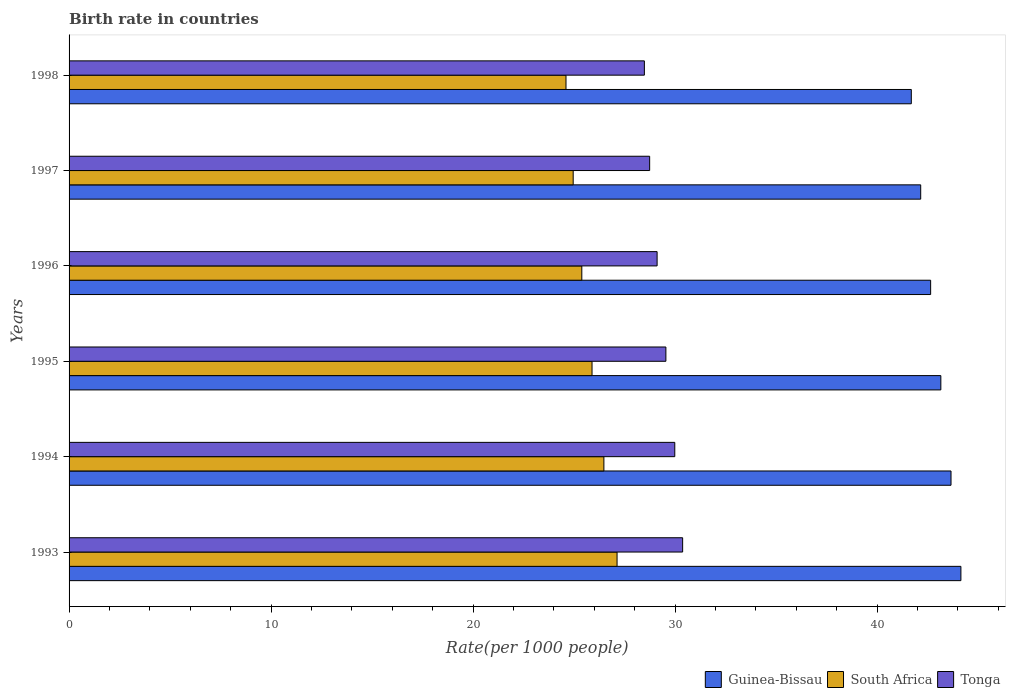Are the number of bars on each tick of the Y-axis equal?
Your answer should be very brief. Yes. How many bars are there on the 1st tick from the bottom?
Ensure brevity in your answer.  3. In how many cases, is the number of bars for a given year not equal to the number of legend labels?
Your response must be concise. 0. What is the birth rate in South Africa in 1996?
Give a very brief answer. 25.38. Across all years, what is the maximum birth rate in Guinea-Bissau?
Your response must be concise. 44.15. Across all years, what is the minimum birth rate in Tonga?
Provide a succinct answer. 28.48. In which year was the birth rate in Guinea-Bissau maximum?
Provide a succinct answer. 1993. In which year was the birth rate in Tonga minimum?
Provide a short and direct response. 1998. What is the total birth rate in Tonga in the graph?
Provide a short and direct response. 176.22. What is the difference between the birth rate in South Africa in 1995 and that in 1997?
Your answer should be very brief. 0.93. What is the difference between the birth rate in South Africa in 1993 and the birth rate in Tonga in 1996?
Make the answer very short. -1.98. What is the average birth rate in Guinea-Bissau per year?
Make the answer very short. 42.91. In the year 1996, what is the difference between the birth rate in Guinea-Bissau and birth rate in South Africa?
Offer a very short reply. 17.27. What is the ratio of the birth rate in South Africa in 1997 to that in 1998?
Make the answer very short. 1.01. Is the birth rate in South Africa in 1994 less than that in 1995?
Provide a short and direct response. No. What is the difference between the highest and the second highest birth rate in Tonga?
Provide a short and direct response. 0.39. What is the difference between the highest and the lowest birth rate in South Africa?
Your answer should be compact. 2.53. In how many years, is the birth rate in Guinea-Bissau greater than the average birth rate in Guinea-Bissau taken over all years?
Your response must be concise. 3. Is the sum of the birth rate in South Africa in 1995 and 1996 greater than the maximum birth rate in Guinea-Bissau across all years?
Ensure brevity in your answer.  Yes. What does the 3rd bar from the top in 1996 represents?
Keep it short and to the point. Guinea-Bissau. What does the 1st bar from the bottom in 1993 represents?
Your answer should be very brief. Guinea-Bissau. Is it the case that in every year, the sum of the birth rate in South Africa and birth rate in Tonga is greater than the birth rate in Guinea-Bissau?
Make the answer very short. Yes. Are all the bars in the graph horizontal?
Keep it short and to the point. Yes. What is the difference between two consecutive major ticks on the X-axis?
Your answer should be very brief. 10. Does the graph contain any zero values?
Offer a terse response. No. Does the graph contain grids?
Offer a very short reply. No. What is the title of the graph?
Offer a very short reply. Birth rate in countries. What is the label or title of the X-axis?
Provide a succinct answer. Rate(per 1000 people). What is the Rate(per 1000 people) in Guinea-Bissau in 1993?
Offer a terse response. 44.15. What is the Rate(per 1000 people) in South Africa in 1993?
Ensure brevity in your answer.  27.13. What is the Rate(per 1000 people) of Tonga in 1993?
Offer a very short reply. 30.37. What is the Rate(per 1000 people) of Guinea-Bissau in 1994?
Offer a very short reply. 43.66. What is the Rate(per 1000 people) in South Africa in 1994?
Your answer should be compact. 26.47. What is the Rate(per 1000 people) of Tonga in 1994?
Offer a very short reply. 29.98. What is the Rate(per 1000 people) in Guinea-Bissau in 1995?
Make the answer very short. 43.15. What is the Rate(per 1000 people) in South Africa in 1995?
Your response must be concise. 25.89. What is the Rate(per 1000 people) of Tonga in 1995?
Your response must be concise. 29.54. What is the Rate(per 1000 people) of Guinea-Bissau in 1996?
Keep it short and to the point. 42.65. What is the Rate(per 1000 people) of South Africa in 1996?
Make the answer very short. 25.38. What is the Rate(per 1000 people) of Tonga in 1996?
Your response must be concise. 29.11. What is the Rate(per 1000 people) of Guinea-Bissau in 1997?
Provide a short and direct response. 42.16. What is the Rate(per 1000 people) of South Africa in 1997?
Offer a very short reply. 24.95. What is the Rate(per 1000 people) in Tonga in 1997?
Your answer should be compact. 28.74. What is the Rate(per 1000 people) of Guinea-Bissau in 1998?
Offer a very short reply. 41.69. What is the Rate(per 1000 people) in South Africa in 1998?
Your answer should be very brief. 24.6. What is the Rate(per 1000 people) in Tonga in 1998?
Offer a very short reply. 28.48. Across all years, what is the maximum Rate(per 1000 people) of Guinea-Bissau?
Keep it short and to the point. 44.15. Across all years, what is the maximum Rate(per 1000 people) of South Africa?
Your answer should be very brief. 27.13. Across all years, what is the maximum Rate(per 1000 people) in Tonga?
Offer a terse response. 30.37. Across all years, what is the minimum Rate(per 1000 people) of Guinea-Bissau?
Ensure brevity in your answer.  41.69. Across all years, what is the minimum Rate(per 1000 people) in South Africa?
Make the answer very short. 24.6. Across all years, what is the minimum Rate(per 1000 people) of Tonga?
Keep it short and to the point. 28.48. What is the total Rate(per 1000 people) in Guinea-Bissau in the graph?
Your answer should be compact. 257.45. What is the total Rate(per 1000 people) in South Africa in the graph?
Your response must be concise. 154.42. What is the total Rate(per 1000 people) in Tonga in the graph?
Ensure brevity in your answer.  176.22. What is the difference between the Rate(per 1000 people) of Guinea-Bissau in 1993 and that in 1994?
Provide a succinct answer. 0.49. What is the difference between the Rate(per 1000 people) of South Africa in 1993 and that in 1994?
Offer a terse response. 0.65. What is the difference between the Rate(per 1000 people) of Tonga in 1993 and that in 1994?
Ensure brevity in your answer.  0.39. What is the difference between the Rate(per 1000 people) of South Africa in 1993 and that in 1995?
Keep it short and to the point. 1.24. What is the difference between the Rate(per 1000 people) in Tonga in 1993 and that in 1995?
Your answer should be compact. 0.83. What is the difference between the Rate(per 1000 people) of Guinea-Bissau in 1993 and that in 1996?
Ensure brevity in your answer.  1.5. What is the difference between the Rate(per 1000 people) in South Africa in 1993 and that in 1996?
Give a very brief answer. 1.75. What is the difference between the Rate(per 1000 people) of Tonga in 1993 and that in 1996?
Give a very brief answer. 1.26. What is the difference between the Rate(per 1000 people) in Guinea-Bissau in 1993 and that in 1997?
Provide a succinct answer. 1.99. What is the difference between the Rate(per 1000 people) of South Africa in 1993 and that in 1997?
Make the answer very short. 2.17. What is the difference between the Rate(per 1000 people) of Tonga in 1993 and that in 1997?
Give a very brief answer. 1.63. What is the difference between the Rate(per 1000 people) in Guinea-Bissau in 1993 and that in 1998?
Provide a succinct answer. 2.46. What is the difference between the Rate(per 1000 people) in South Africa in 1993 and that in 1998?
Keep it short and to the point. 2.53. What is the difference between the Rate(per 1000 people) in Tonga in 1993 and that in 1998?
Provide a succinct answer. 1.89. What is the difference between the Rate(per 1000 people) of Guinea-Bissau in 1994 and that in 1995?
Keep it short and to the point. 0.5. What is the difference between the Rate(per 1000 people) of South Africa in 1994 and that in 1995?
Offer a very short reply. 0.59. What is the difference between the Rate(per 1000 people) in Tonga in 1994 and that in 1995?
Keep it short and to the point. 0.44. What is the difference between the Rate(per 1000 people) of Guinea-Bissau in 1994 and that in 1996?
Provide a succinct answer. 1.01. What is the difference between the Rate(per 1000 people) in South Africa in 1994 and that in 1996?
Your answer should be very brief. 1.09. What is the difference between the Rate(per 1000 people) of Guinea-Bissau in 1994 and that in 1997?
Provide a short and direct response. 1.5. What is the difference between the Rate(per 1000 people) in South Africa in 1994 and that in 1997?
Ensure brevity in your answer.  1.52. What is the difference between the Rate(per 1000 people) in Tonga in 1994 and that in 1997?
Your answer should be very brief. 1.24. What is the difference between the Rate(per 1000 people) of Guinea-Bissau in 1994 and that in 1998?
Your response must be concise. 1.97. What is the difference between the Rate(per 1000 people) in South Africa in 1994 and that in 1998?
Offer a very short reply. 1.88. What is the difference between the Rate(per 1000 people) in Tonga in 1994 and that in 1998?
Ensure brevity in your answer.  1.5. What is the difference between the Rate(per 1000 people) in Guinea-Bissau in 1995 and that in 1996?
Ensure brevity in your answer.  0.51. What is the difference between the Rate(per 1000 people) in South Africa in 1995 and that in 1996?
Give a very brief answer. 0.51. What is the difference between the Rate(per 1000 people) in Tonga in 1995 and that in 1996?
Your response must be concise. 0.43. What is the difference between the Rate(per 1000 people) of South Africa in 1995 and that in 1997?
Make the answer very short. 0.93. What is the difference between the Rate(per 1000 people) of Tonga in 1995 and that in 1997?
Give a very brief answer. 0.8. What is the difference between the Rate(per 1000 people) in Guinea-Bissau in 1995 and that in 1998?
Ensure brevity in your answer.  1.46. What is the difference between the Rate(per 1000 people) of South Africa in 1995 and that in 1998?
Offer a very short reply. 1.29. What is the difference between the Rate(per 1000 people) in Tonga in 1995 and that in 1998?
Provide a succinct answer. 1.06. What is the difference between the Rate(per 1000 people) of Guinea-Bissau in 1996 and that in 1997?
Give a very brief answer. 0.49. What is the difference between the Rate(per 1000 people) in South Africa in 1996 and that in 1997?
Your response must be concise. 0.43. What is the difference between the Rate(per 1000 people) in Tonga in 1996 and that in 1997?
Provide a succinct answer. 0.37. What is the difference between the Rate(per 1000 people) of Guinea-Bissau in 1996 and that in 1998?
Ensure brevity in your answer.  0.96. What is the difference between the Rate(per 1000 people) in South Africa in 1996 and that in 1998?
Your answer should be compact. 0.78. What is the difference between the Rate(per 1000 people) of Tonga in 1996 and that in 1998?
Give a very brief answer. 0.63. What is the difference between the Rate(per 1000 people) in Guinea-Bissau in 1997 and that in 1998?
Offer a terse response. 0.47. What is the difference between the Rate(per 1000 people) of South Africa in 1997 and that in 1998?
Your answer should be compact. 0.36. What is the difference between the Rate(per 1000 people) of Tonga in 1997 and that in 1998?
Your answer should be very brief. 0.26. What is the difference between the Rate(per 1000 people) of Guinea-Bissau in 1993 and the Rate(per 1000 people) of South Africa in 1994?
Your answer should be compact. 17.67. What is the difference between the Rate(per 1000 people) of Guinea-Bissau in 1993 and the Rate(per 1000 people) of Tonga in 1994?
Keep it short and to the point. 14.16. What is the difference between the Rate(per 1000 people) in South Africa in 1993 and the Rate(per 1000 people) in Tonga in 1994?
Keep it short and to the point. -2.86. What is the difference between the Rate(per 1000 people) in Guinea-Bissau in 1993 and the Rate(per 1000 people) in South Africa in 1995?
Offer a terse response. 18.26. What is the difference between the Rate(per 1000 people) in Guinea-Bissau in 1993 and the Rate(per 1000 people) in Tonga in 1995?
Your answer should be very brief. 14.6. What is the difference between the Rate(per 1000 people) of South Africa in 1993 and the Rate(per 1000 people) of Tonga in 1995?
Provide a succinct answer. -2.42. What is the difference between the Rate(per 1000 people) in Guinea-Bissau in 1993 and the Rate(per 1000 people) in South Africa in 1996?
Offer a terse response. 18.77. What is the difference between the Rate(per 1000 people) in Guinea-Bissau in 1993 and the Rate(per 1000 people) in Tonga in 1996?
Your answer should be very brief. 15.04. What is the difference between the Rate(per 1000 people) in South Africa in 1993 and the Rate(per 1000 people) in Tonga in 1996?
Provide a short and direct response. -1.98. What is the difference between the Rate(per 1000 people) in Guinea-Bissau in 1993 and the Rate(per 1000 people) in South Africa in 1997?
Ensure brevity in your answer.  19.19. What is the difference between the Rate(per 1000 people) of Guinea-Bissau in 1993 and the Rate(per 1000 people) of Tonga in 1997?
Make the answer very short. 15.41. What is the difference between the Rate(per 1000 people) in South Africa in 1993 and the Rate(per 1000 people) in Tonga in 1997?
Your answer should be compact. -1.61. What is the difference between the Rate(per 1000 people) of Guinea-Bissau in 1993 and the Rate(per 1000 people) of South Africa in 1998?
Provide a short and direct response. 19.55. What is the difference between the Rate(per 1000 people) of Guinea-Bissau in 1993 and the Rate(per 1000 people) of Tonga in 1998?
Provide a short and direct response. 15.67. What is the difference between the Rate(per 1000 people) in South Africa in 1993 and the Rate(per 1000 people) in Tonga in 1998?
Your answer should be very brief. -1.35. What is the difference between the Rate(per 1000 people) in Guinea-Bissau in 1994 and the Rate(per 1000 people) in South Africa in 1995?
Provide a succinct answer. 17.77. What is the difference between the Rate(per 1000 people) in Guinea-Bissau in 1994 and the Rate(per 1000 people) in Tonga in 1995?
Offer a terse response. 14.11. What is the difference between the Rate(per 1000 people) of South Africa in 1994 and the Rate(per 1000 people) of Tonga in 1995?
Your answer should be compact. -3.07. What is the difference between the Rate(per 1000 people) of Guinea-Bissau in 1994 and the Rate(per 1000 people) of South Africa in 1996?
Provide a succinct answer. 18.28. What is the difference between the Rate(per 1000 people) in Guinea-Bissau in 1994 and the Rate(per 1000 people) in Tonga in 1996?
Your answer should be compact. 14.55. What is the difference between the Rate(per 1000 people) of South Africa in 1994 and the Rate(per 1000 people) of Tonga in 1996?
Offer a very short reply. -2.63. What is the difference between the Rate(per 1000 people) in Guinea-Bissau in 1994 and the Rate(per 1000 people) in South Africa in 1997?
Your answer should be compact. 18.7. What is the difference between the Rate(per 1000 people) of Guinea-Bissau in 1994 and the Rate(per 1000 people) of Tonga in 1997?
Offer a terse response. 14.92. What is the difference between the Rate(per 1000 people) in South Africa in 1994 and the Rate(per 1000 people) in Tonga in 1997?
Offer a very short reply. -2.27. What is the difference between the Rate(per 1000 people) of Guinea-Bissau in 1994 and the Rate(per 1000 people) of South Africa in 1998?
Offer a very short reply. 19.06. What is the difference between the Rate(per 1000 people) in Guinea-Bissau in 1994 and the Rate(per 1000 people) in Tonga in 1998?
Ensure brevity in your answer.  15.18. What is the difference between the Rate(per 1000 people) in South Africa in 1994 and the Rate(per 1000 people) in Tonga in 1998?
Your answer should be very brief. -2. What is the difference between the Rate(per 1000 people) of Guinea-Bissau in 1995 and the Rate(per 1000 people) of South Africa in 1996?
Provide a short and direct response. 17.77. What is the difference between the Rate(per 1000 people) of Guinea-Bissau in 1995 and the Rate(per 1000 people) of Tonga in 1996?
Your answer should be compact. 14.04. What is the difference between the Rate(per 1000 people) in South Africa in 1995 and the Rate(per 1000 people) in Tonga in 1996?
Offer a terse response. -3.22. What is the difference between the Rate(per 1000 people) of Guinea-Bissau in 1995 and the Rate(per 1000 people) of South Africa in 1997?
Ensure brevity in your answer.  18.2. What is the difference between the Rate(per 1000 people) in Guinea-Bissau in 1995 and the Rate(per 1000 people) in Tonga in 1997?
Your response must be concise. 14.41. What is the difference between the Rate(per 1000 people) of South Africa in 1995 and the Rate(per 1000 people) of Tonga in 1997?
Offer a terse response. -2.85. What is the difference between the Rate(per 1000 people) of Guinea-Bissau in 1995 and the Rate(per 1000 people) of South Africa in 1998?
Your response must be concise. 18.55. What is the difference between the Rate(per 1000 people) of Guinea-Bissau in 1995 and the Rate(per 1000 people) of Tonga in 1998?
Ensure brevity in your answer.  14.68. What is the difference between the Rate(per 1000 people) of South Africa in 1995 and the Rate(per 1000 people) of Tonga in 1998?
Keep it short and to the point. -2.59. What is the difference between the Rate(per 1000 people) of Guinea-Bissau in 1996 and the Rate(per 1000 people) of South Africa in 1997?
Give a very brief answer. 17.69. What is the difference between the Rate(per 1000 people) of Guinea-Bissau in 1996 and the Rate(per 1000 people) of Tonga in 1997?
Your response must be concise. 13.91. What is the difference between the Rate(per 1000 people) in South Africa in 1996 and the Rate(per 1000 people) in Tonga in 1997?
Your answer should be very brief. -3.36. What is the difference between the Rate(per 1000 people) of Guinea-Bissau in 1996 and the Rate(per 1000 people) of South Africa in 1998?
Ensure brevity in your answer.  18.05. What is the difference between the Rate(per 1000 people) of Guinea-Bissau in 1996 and the Rate(per 1000 people) of Tonga in 1998?
Your answer should be compact. 14.17. What is the difference between the Rate(per 1000 people) of South Africa in 1996 and the Rate(per 1000 people) of Tonga in 1998?
Offer a terse response. -3.1. What is the difference between the Rate(per 1000 people) of Guinea-Bissau in 1997 and the Rate(per 1000 people) of South Africa in 1998?
Your answer should be very brief. 17.56. What is the difference between the Rate(per 1000 people) of Guinea-Bissau in 1997 and the Rate(per 1000 people) of Tonga in 1998?
Your answer should be compact. 13.68. What is the difference between the Rate(per 1000 people) of South Africa in 1997 and the Rate(per 1000 people) of Tonga in 1998?
Give a very brief answer. -3.52. What is the average Rate(per 1000 people) of Guinea-Bissau per year?
Offer a terse response. 42.91. What is the average Rate(per 1000 people) of South Africa per year?
Your answer should be very brief. 25.74. What is the average Rate(per 1000 people) in Tonga per year?
Your response must be concise. 29.37. In the year 1993, what is the difference between the Rate(per 1000 people) in Guinea-Bissau and Rate(per 1000 people) in South Africa?
Your answer should be compact. 17.02. In the year 1993, what is the difference between the Rate(per 1000 people) in Guinea-Bissau and Rate(per 1000 people) in Tonga?
Provide a short and direct response. 13.77. In the year 1993, what is the difference between the Rate(per 1000 people) of South Africa and Rate(per 1000 people) of Tonga?
Provide a short and direct response. -3.25. In the year 1994, what is the difference between the Rate(per 1000 people) in Guinea-Bissau and Rate(per 1000 people) in South Africa?
Give a very brief answer. 17.18. In the year 1994, what is the difference between the Rate(per 1000 people) of Guinea-Bissau and Rate(per 1000 people) of Tonga?
Make the answer very short. 13.67. In the year 1994, what is the difference between the Rate(per 1000 people) in South Africa and Rate(per 1000 people) in Tonga?
Give a very brief answer. -3.51. In the year 1995, what is the difference between the Rate(per 1000 people) of Guinea-Bissau and Rate(per 1000 people) of South Africa?
Your answer should be very brief. 17.27. In the year 1995, what is the difference between the Rate(per 1000 people) in Guinea-Bissau and Rate(per 1000 people) in Tonga?
Your answer should be very brief. 13.61. In the year 1995, what is the difference between the Rate(per 1000 people) in South Africa and Rate(per 1000 people) in Tonga?
Offer a very short reply. -3.66. In the year 1996, what is the difference between the Rate(per 1000 people) in Guinea-Bissau and Rate(per 1000 people) in South Africa?
Your answer should be very brief. 17.27. In the year 1996, what is the difference between the Rate(per 1000 people) in Guinea-Bissau and Rate(per 1000 people) in Tonga?
Your response must be concise. 13.54. In the year 1996, what is the difference between the Rate(per 1000 people) in South Africa and Rate(per 1000 people) in Tonga?
Offer a terse response. -3.73. In the year 1997, what is the difference between the Rate(per 1000 people) in Guinea-Bissau and Rate(per 1000 people) in South Africa?
Ensure brevity in your answer.  17.2. In the year 1997, what is the difference between the Rate(per 1000 people) in Guinea-Bissau and Rate(per 1000 people) in Tonga?
Your answer should be very brief. 13.42. In the year 1997, what is the difference between the Rate(per 1000 people) in South Africa and Rate(per 1000 people) in Tonga?
Provide a succinct answer. -3.79. In the year 1998, what is the difference between the Rate(per 1000 people) of Guinea-Bissau and Rate(per 1000 people) of South Africa?
Your answer should be compact. 17.09. In the year 1998, what is the difference between the Rate(per 1000 people) of Guinea-Bissau and Rate(per 1000 people) of Tonga?
Give a very brief answer. 13.21. In the year 1998, what is the difference between the Rate(per 1000 people) of South Africa and Rate(per 1000 people) of Tonga?
Your answer should be compact. -3.88. What is the ratio of the Rate(per 1000 people) in Guinea-Bissau in 1993 to that in 1994?
Provide a succinct answer. 1.01. What is the ratio of the Rate(per 1000 people) in South Africa in 1993 to that in 1994?
Provide a short and direct response. 1.02. What is the ratio of the Rate(per 1000 people) in Tonga in 1993 to that in 1994?
Provide a short and direct response. 1.01. What is the ratio of the Rate(per 1000 people) of Guinea-Bissau in 1993 to that in 1995?
Make the answer very short. 1.02. What is the ratio of the Rate(per 1000 people) of South Africa in 1993 to that in 1995?
Offer a terse response. 1.05. What is the ratio of the Rate(per 1000 people) in Tonga in 1993 to that in 1995?
Offer a terse response. 1.03. What is the ratio of the Rate(per 1000 people) in Guinea-Bissau in 1993 to that in 1996?
Provide a short and direct response. 1.04. What is the ratio of the Rate(per 1000 people) of South Africa in 1993 to that in 1996?
Your answer should be very brief. 1.07. What is the ratio of the Rate(per 1000 people) of Tonga in 1993 to that in 1996?
Keep it short and to the point. 1.04. What is the ratio of the Rate(per 1000 people) in Guinea-Bissau in 1993 to that in 1997?
Provide a short and direct response. 1.05. What is the ratio of the Rate(per 1000 people) of South Africa in 1993 to that in 1997?
Give a very brief answer. 1.09. What is the ratio of the Rate(per 1000 people) of Tonga in 1993 to that in 1997?
Your answer should be compact. 1.06. What is the ratio of the Rate(per 1000 people) of Guinea-Bissau in 1993 to that in 1998?
Provide a short and direct response. 1.06. What is the ratio of the Rate(per 1000 people) in South Africa in 1993 to that in 1998?
Ensure brevity in your answer.  1.1. What is the ratio of the Rate(per 1000 people) of Tonga in 1993 to that in 1998?
Offer a very short reply. 1.07. What is the ratio of the Rate(per 1000 people) in Guinea-Bissau in 1994 to that in 1995?
Ensure brevity in your answer.  1.01. What is the ratio of the Rate(per 1000 people) of South Africa in 1994 to that in 1995?
Your response must be concise. 1.02. What is the ratio of the Rate(per 1000 people) of Tonga in 1994 to that in 1995?
Provide a short and direct response. 1.01. What is the ratio of the Rate(per 1000 people) of Guinea-Bissau in 1994 to that in 1996?
Ensure brevity in your answer.  1.02. What is the ratio of the Rate(per 1000 people) in South Africa in 1994 to that in 1996?
Provide a succinct answer. 1.04. What is the ratio of the Rate(per 1000 people) of Tonga in 1994 to that in 1996?
Keep it short and to the point. 1.03. What is the ratio of the Rate(per 1000 people) in Guinea-Bissau in 1994 to that in 1997?
Make the answer very short. 1.04. What is the ratio of the Rate(per 1000 people) of South Africa in 1994 to that in 1997?
Provide a succinct answer. 1.06. What is the ratio of the Rate(per 1000 people) in Tonga in 1994 to that in 1997?
Ensure brevity in your answer.  1.04. What is the ratio of the Rate(per 1000 people) in Guinea-Bissau in 1994 to that in 1998?
Provide a succinct answer. 1.05. What is the ratio of the Rate(per 1000 people) of South Africa in 1994 to that in 1998?
Offer a terse response. 1.08. What is the ratio of the Rate(per 1000 people) in Tonga in 1994 to that in 1998?
Make the answer very short. 1.05. What is the ratio of the Rate(per 1000 people) of Guinea-Bissau in 1995 to that in 1996?
Your answer should be very brief. 1.01. What is the ratio of the Rate(per 1000 people) of South Africa in 1995 to that in 1996?
Your answer should be compact. 1.02. What is the ratio of the Rate(per 1000 people) of Tonga in 1995 to that in 1996?
Provide a succinct answer. 1.01. What is the ratio of the Rate(per 1000 people) in Guinea-Bissau in 1995 to that in 1997?
Make the answer very short. 1.02. What is the ratio of the Rate(per 1000 people) of South Africa in 1995 to that in 1997?
Keep it short and to the point. 1.04. What is the ratio of the Rate(per 1000 people) of Tonga in 1995 to that in 1997?
Provide a succinct answer. 1.03. What is the ratio of the Rate(per 1000 people) of Guinea-Bissau in 1995 to that in 1998?
Provide a short and direct response. 1.04. What is the ratio of the Rate(per 1000 people) of South Africa in 1995 to that in 1998?
Your answer should be compact. 1.05. What is the ratio of the Rate(per 1000 people) in Tonga in 1995 to that in 1998?
Ensure brevity in your answer.  1.04. What is the ratio of the Rate(per 1000 people) in Guinea-Bissau in 1996 to that in 1997?
Provide a short and direct response. 1.01. What is the ratio of the Rate(per 1000 people) of South Africa in 1996 to that in 1997?
Ensure brevity in your answer.  1.02. What is the ratio of the Rate(per 1000 people) of Tonga in 1996 to that in 1997?
Ensure brevity in your answer.  1.01. What is the ratio of the Rate(per 1000 people) in Guinea-Bissau in 1996 to that in 1998?
Provide a succinct answer. 1.02. What is the ratio of the Rate(per 1000 people) of South Africa in 1996 to that in 1998?
Offer a terse response. 1.03. What is the ratio of the Rate(per 1000 people) of Tonga in 1996 to that in 1998?
Offer a terse response. 1.02. What is the ratio of the Rate(per 1000 people) in Guinea-Bissau in 1997 to that in 1998?
Offer a terse response. 1.01. What is the ratio of the Rate(per 1000 people) of South Africa in 1997 to that in 1998?
Give a very brief answer. 1.01. What is the ratio of the Rate(per 1000 people) of Tonga in 1997 to that in 1998?
Offer a very short reply. 1.01. What is the difference between the highest and the second highest Rate(per 1000 people) in Guinea-Bissau?
Your answer should be compact. 0.49. What is the difference between the highest and the second highest Rate(per 1000 people) in South Africa?
Provide a short and direct response. 0.65. What is the difference between the highest and the second highest Rate(per 1000 people) of Tonga?
Your answer should be very brief. 0.39. What is the difference between the highest and the lowest Rate(per 1000 people) in Guinea-Bissau?
Ensure brevity in your answer.  2.46. What is the difference between the highest and the lowest Rate(per 1000 people) of South Africa?
Provide a short and direct response. 2.53. What is the difference between the highest and the lowest Rate(per 1000 people) of Tonga?
Offer a terse response. 1.89. 